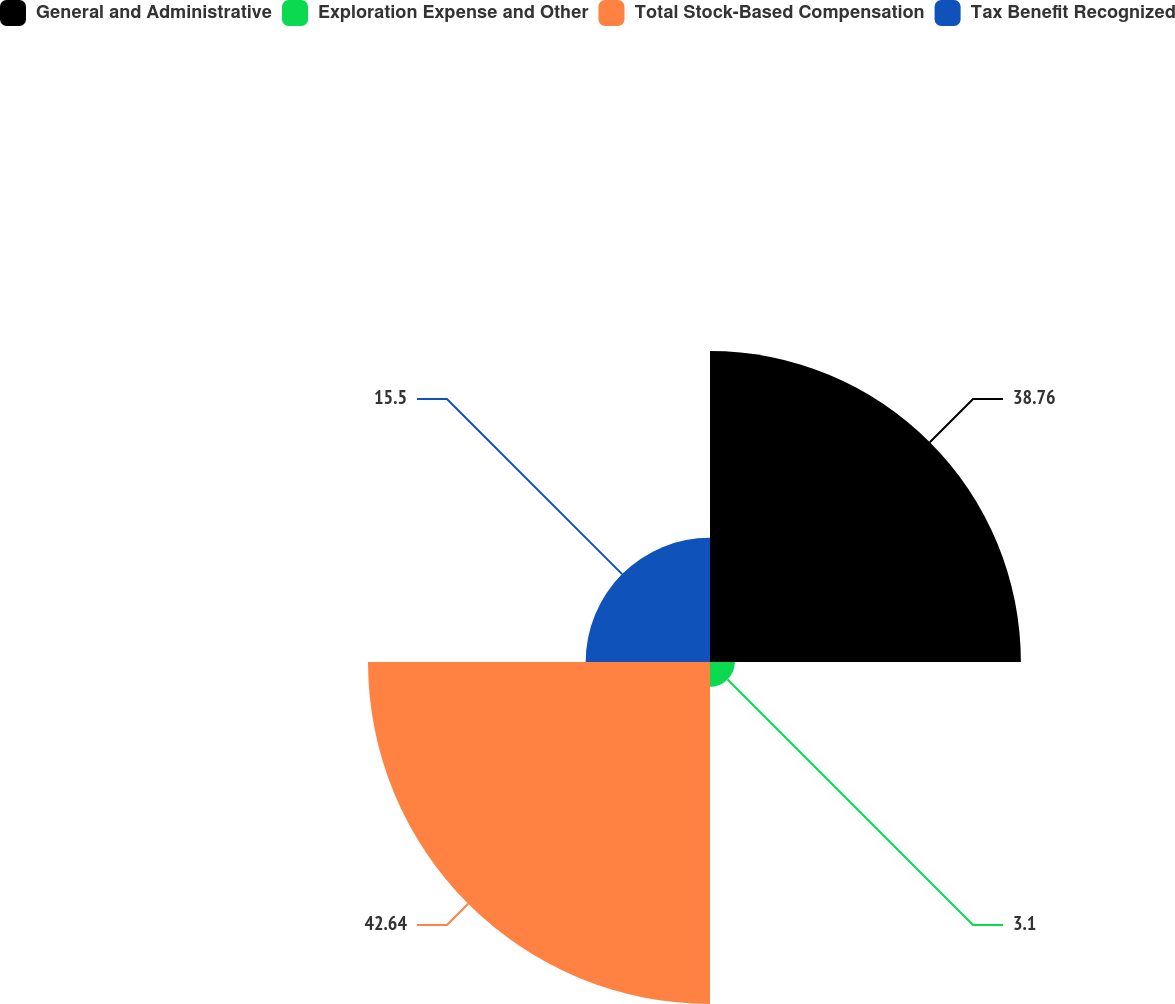Convert chart. <chart><loc_0><loc_0><loc_500><loc_500><pie_chart><fcel>General and Administrative<fcel>Exploration Expense and Other<fcel>Total Stock-Based Compensation<fcel>Tax Benefit Recognized<nl><fcel>38.76%<fcel>3.1%<fcel>42.64%<fcel>15.5%<nl></chart> 